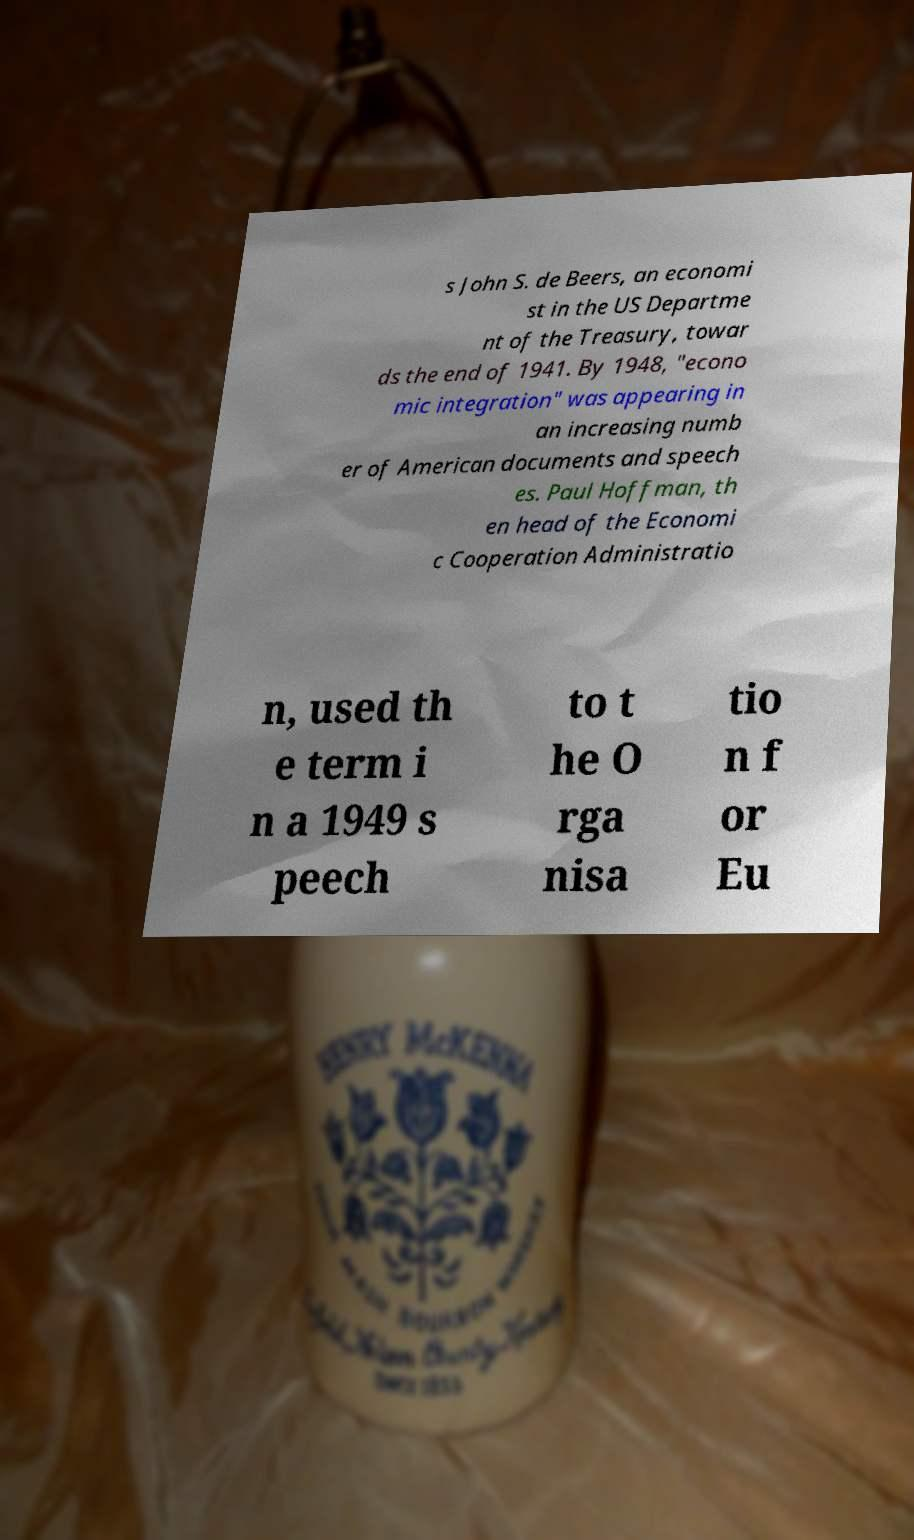Could you assist in decoding the text presented in this image and type it out clearly? s John S. de Beers, an economi st in the US Departme nt of the Treasury, towar ds the end of 1941. By 1948, "econo mic integration" was appearing in an increasing numb er of American documents and speech es. Paul Hoffman, th en head of the Economi c Cooperation Administratio n, used th e term i n a 1949 s peech to t he O rga nisa tio n f or Eu 